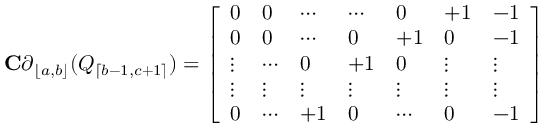<formula> <loc_0><loc_0><loc_500><loc_500>C \partial _ { \lfloor a , b \rfloor } ( Q _ { \lceil b - 1 , c + 1 \rceil } ) = \left [ \begin{array} { l l l l l l l } { 0 } & { 0 } & { \cdots } & { \cdots } & { 0 } & { + 1 } & { - 1 } \\ { 0 } & { 0 } & { \cdots } & { 0 } & { + 1 } & { 0 } & { - 1 } \\ { \vdots } & { \cdots } & { 0 } & { + 1 } & { 0 } & { \vdots } & { \vdots } \\ { \vdots } & { \vdots } & { \vdots } & { \vdots } & { \vdots } & { \vdots } & { \vdots } \\ { 0 } & { \cdots } & { + 1 } & { 0 } & { \cdots } & { 0 } & { - 1 } \end{array} \right ]</formula> 